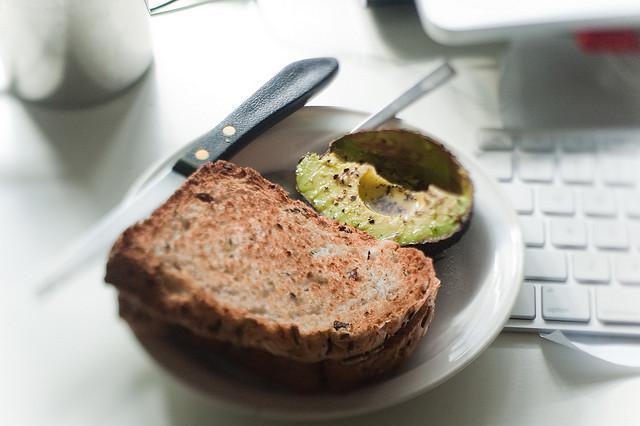Is "The sandwich is at the left side of the bowl." an appropriate description for the image?
Answer yes or no. No. Does the caption "The sandwich is in the bowl." correctly depict the image?
Answer yes or no. Yes. Evaluate: Does the caption "The bowl contains the sandwich." match the image?
Answer yes or no. Yes. 